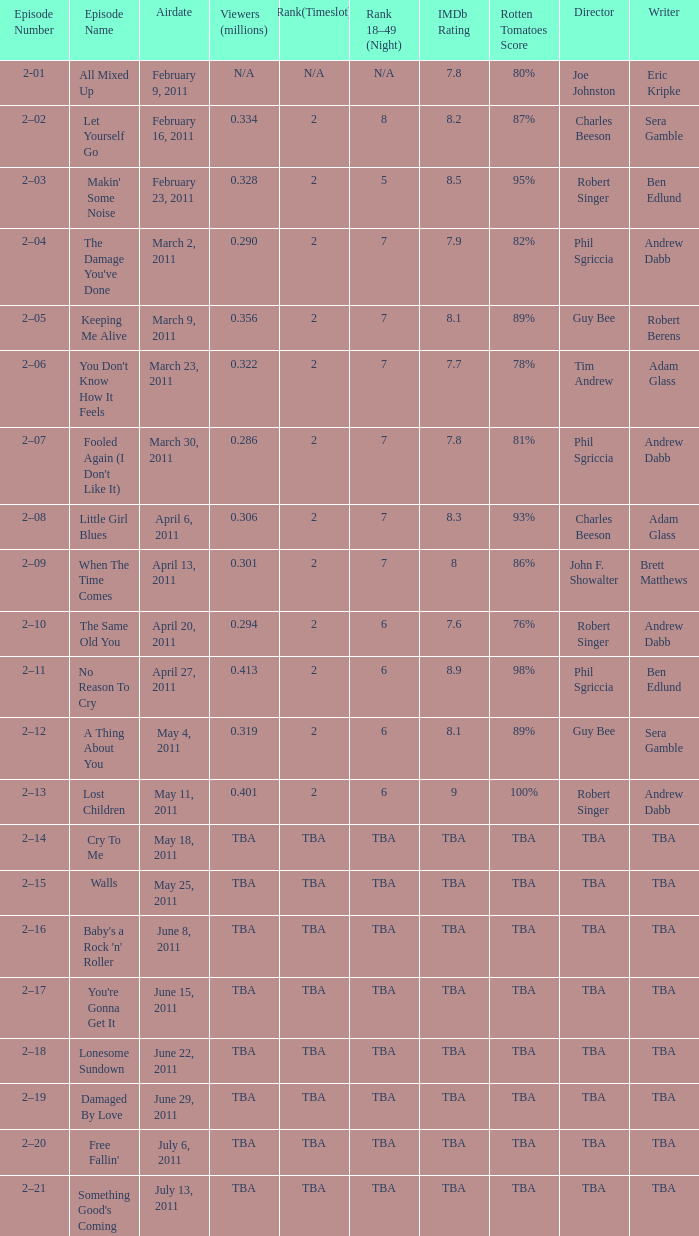What is the total rank on airdate march 30, 2011? 1.0. 